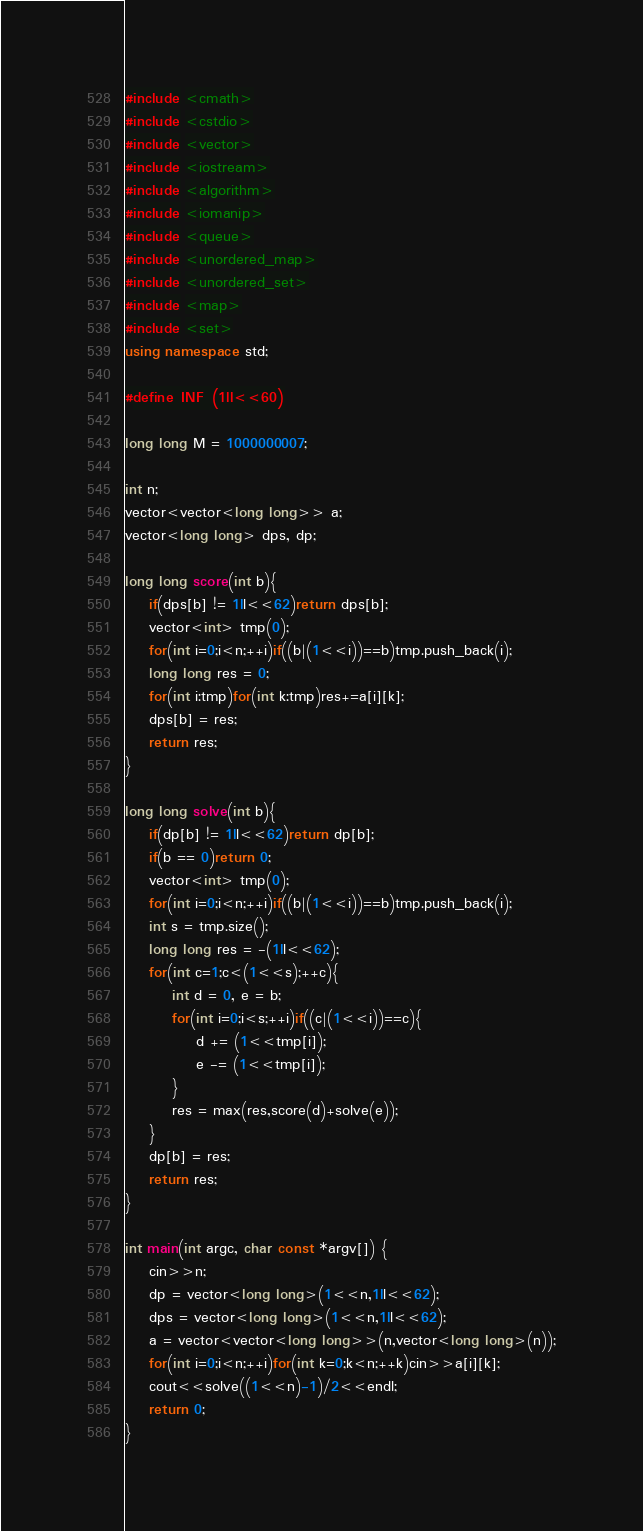Convert code to text. <code><loc_0><loc_0><loc_500><loc_500><_C++_>#include <cmath>
#include <cstdio>
#include <vector>
#include <iostream>
#include <algorithm>
#include <iomanip>
#include <queue>
#include <unordered_map>
#include <unordered_set>
#include <map>
#include <set>
using namespace std;

#define INF (1ll<<60)

long long M = 1000000007;

int n;
vector<vector<long long>> a;
vector<long long> dps, dp;

long long score(int b){
    if(dps[b] != 1ll<<62)return dps[b];
    vector<int> tmp(0);
    for(int i=0;i<n;++i)if((b|(1<<i))==b)tmp.push_back(i);
    long long res = 0;
    for(int i:tmp)for(int k:tmp)res+=a[i][k];
    dps[b] = res;
    return res;
}

long long solve(int b){
    if(dp[b] != 1ll<<62)return dp[b];
    if(b == 0)return 0;
    vector<int> tmp(0);
    for(int i=0;i<n;++i)if((b|(1<<i))==b)tmp.push_back(i);
    int s = tmp.size();
    long long res = -(1ll<<62);
    for(int c=1;c<(1<<s);++c){
        int d = 0, e = b;
        for(int i=0;i<s;++i)if((c|(1<<i))==c){
            d += (1<<tmp[i]);
            e -= (1<<tmp[i]);
        }
        res = max(res,score(d)+solve(e));
    }
    dp[b] = res;
    return res;
}

int main(int argc, char const *argv[]) {
    cin>>n;
    dp = vector<long long>(1<<n,1ll<<62);
    dps = vector<long long>(1<<n,1ll<<62);
    a = vector<vector<long long>>(n,vector<long long>(n));
    for(int i=0;i<n;++i)for(int k=0;k<n;++k)cin>>a[i][k];
    cout<<solve((1<<n)-1)/2<<endl;
    return 0;
}</code> 